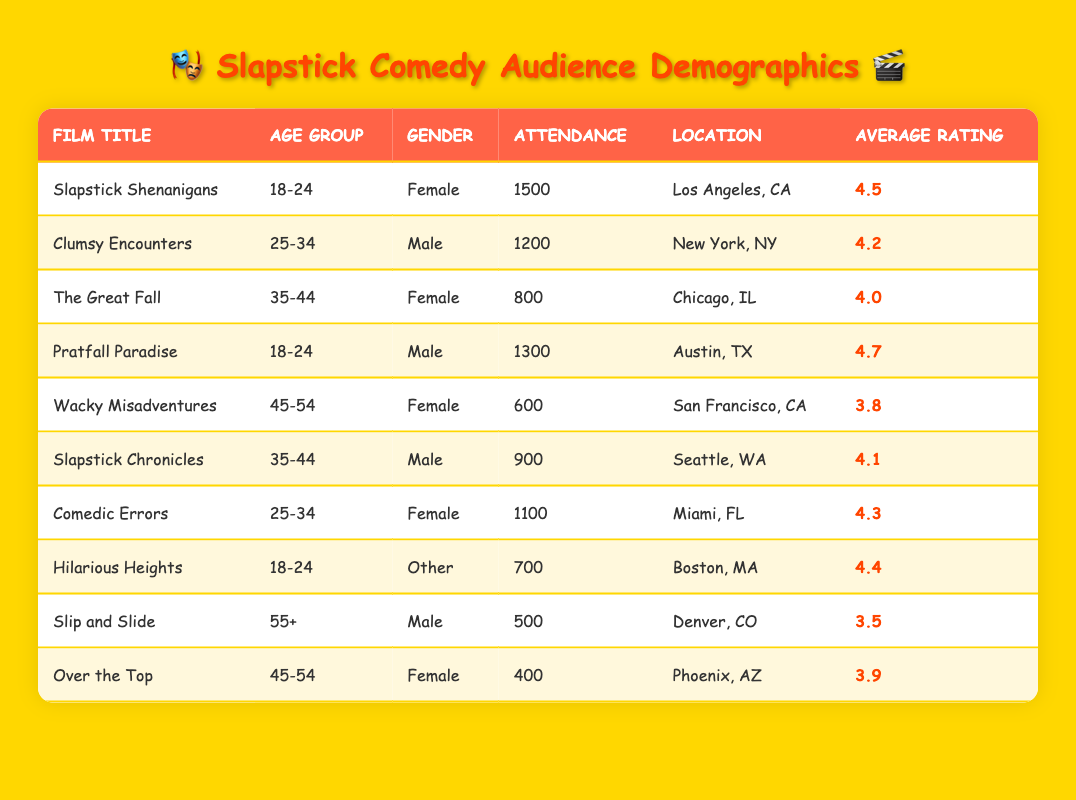What was the average attendance for films targeted at the 18-24 age group? The films targeted at the 18-24 age group are "Slapstick Shenanigans" with an attendance of 1500, "Pratfall Paradise" with an attendance of 1300, and "Hilarious Heights" with an attendance of 700. To find the average, we sum these values: 1500 + 1300 + 700 = 3500. Then we divide by the number of films (3), resulting in an average attendance of 3500 / 3 = 1166.67.
Answer: 1166.67 Which film had the highest average rating among female audiences? "Slapstick Shenanigans" had an average rating of 4.5 (attendance 1500), "The Great Fall" had 4.0 (attendance 800), "Comedic Errors" had 4.3 (attendance 1100), "Wacky Misadventures" had 3.8 (attendance 600), and "Over the Top" had 3.9 (attendance 400). The highest rating among these is 4.5 from "Slapstick Shenanigans."
Answer: Slapstick Shenanigans Did any films screened in 2022 receive an average rating of 4.5 or higher? Yes, the following films received an average rating of 4.5 or higher: "Slapstick Shenanigans" (4.5), "Pratfall Paradise" (4.7), and "Hilarious Heights" (4.4). Therefore, there are films with ratings of 4.5 and above.
Answer: Yes Which age group had the lowest attendance across all films? The films with the lowest attendance are "Over the Top" (400) for the age group 45-54, "Slip and Slide" (500) for the age group 55+, and "Wacky Misadventures" (600) for the age group 45-54. The lowest attendance of 400 belongs to the 45-54 age group in "Over the Top."
Answer: 400 What is the total attendance for male audiences across all films? The male audience attendance includes "Clumsy Encounters" (1200), "Pratfall Paradise" (1300), "Slapstick Chronicles" (900), and "Slip and Slide" (500). Adding these together gives us 1200 + 1300 + 900 + 500 = 3900.
Answer: 3900 Which location had the highest attendance for a film in 2022? The highest attendance was for "Slapstick Shenanigans" in Los Angeles, CA with 1500 attendees. Other films have lower attendance: "Clumsy Encounters" in New York, NY had 1200. So, Los Angeles is the highest at 1500.
Answer: Los Angeles, CA What is the difference in attendance between the films with the title "Over the Top" and "Slapstick Shenanigans"? "Over the Top" had an attendance of 400, while "Slapstick Shenanigans" had 1500. The difference in attendance is calculated by subtracting the smaller from the larger: 1500 - 400 = 1100.
Answer: 1100 Are there more male or female attendees across all films? Total female attendance includes: "Slapstick Shenanigans" (1500), "The Great Fall" (800), "Comedic Errors" (1100), "Wacky Misadventures" (600), and "Over the Top" (400), summing to 1500 + 800 + 1100 + 600 + 400 = 4400. Male attendance includes: "Clumsy Encounters" (1200), "Pratfall Paradise" (1300), "Slapstick Chronicles" (900), and "Slip and Slide" (500), summing to 1200 + 1300 + 900 + 500 = 3900. Since 4400 > 3900, there are more female attendees.
Answer: Yes 